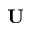Convert formula to latex. <formula><loc_0><loc_0><loc_500><loc_500>U</formula> 